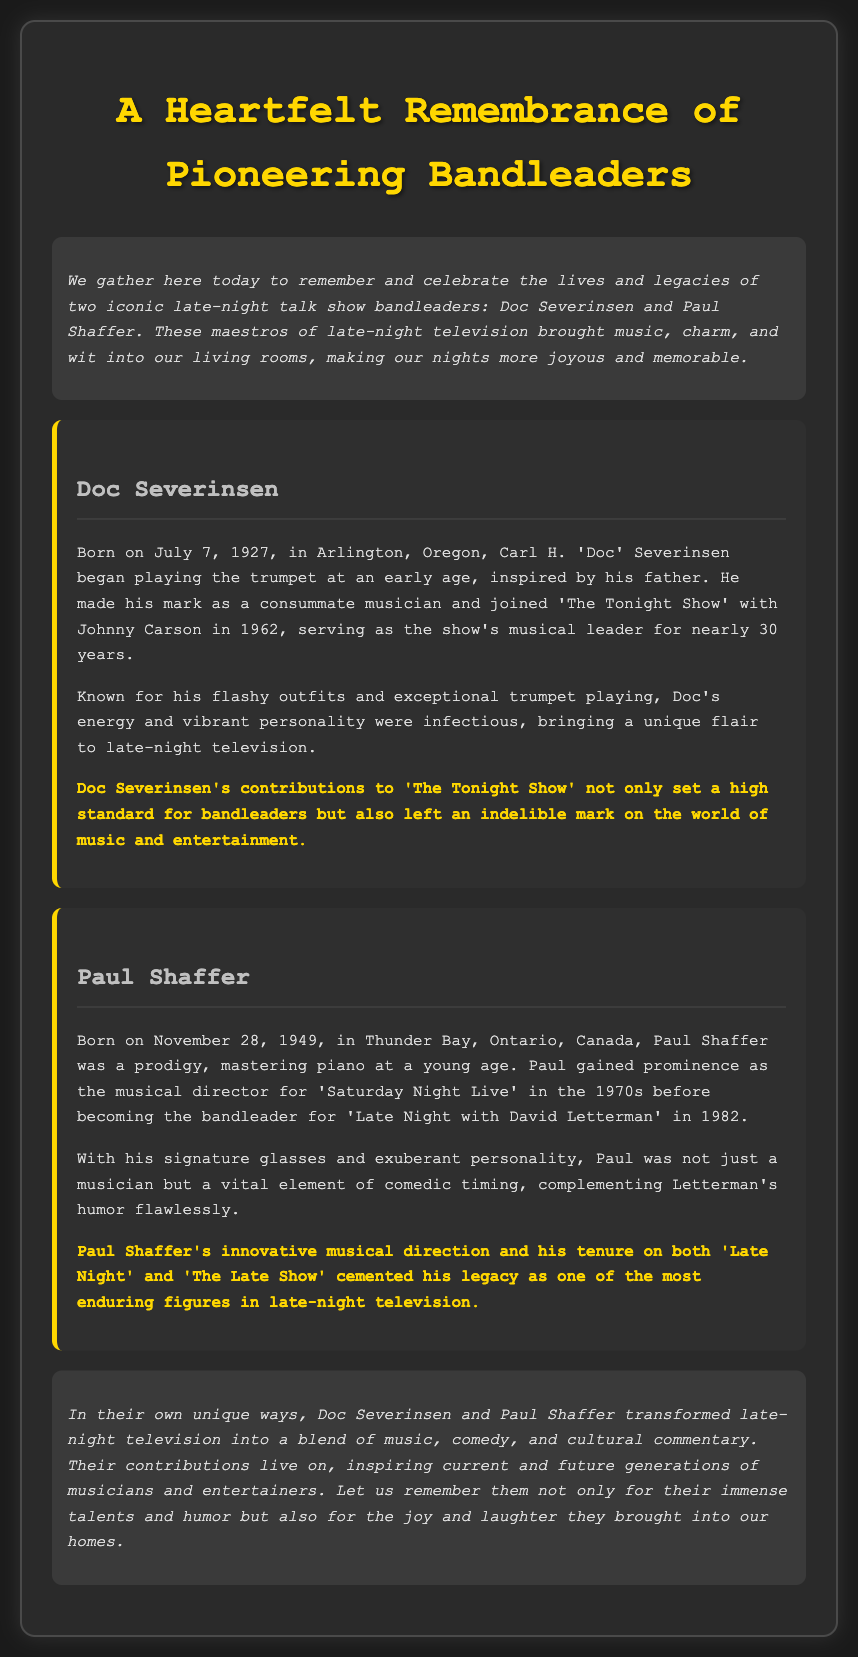What is the birth date of Doc Severinsen? The document explicitly states Doc Severinsen was born on July 7, 1927, in Arlington, Oregon.
Answer: July 7, 1927 What show did Paul Shaffer become the bandleader for in 1982? The document mentions that Paul Shaffer became the bandleader for 'Late Night with David Letterman' in 1982.
Answer: 'Late Night with David Letterman' How long did Doc Severinsen serve as the musical leader for 'The Tonight Show'? The document indicates that Doc Severinsen served as the show's musical leader for nearly 30 years.
Answer: nearly 30 years Which country does Paul Shaffer hail from? The document states that Paul Shaffer was born in Thunder Bay, Ontario, Canada.
Answer: Canada What is a notable aspect of Doc Severinsen's personality mentioned in the document? The document describes Doc Severinsen's energy and vibrant personality, indicating his unique flair in late-night television.
Answer: energy and vibrant personality In which era did Paul Shaffer gain prominence as the musical director? The document notes that Paul Shaffer gained prominence as the musical director for 'Saturday Night Live' in the 1970s.
Answer: 1970s What was the primary theme of the document? The document is a eulogy that celebrates the contributions and legacies of pioneering bandleaders in late-night television.
Answer: celebration of contributions and legacies How does the document describe the contributions of Doc Severinsen? The document states that Doc Severinsen's contributions to 'The Tonight Show' set a high standard for bandleaders.
Answer: set a high standard for bandleaders What element of comedic timing does Paul Shaffer complement? The document indicates that Paul Shaffer complemented Letterman's humor flawlessly.
Answer: Letterman's humor 